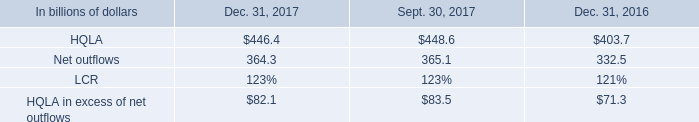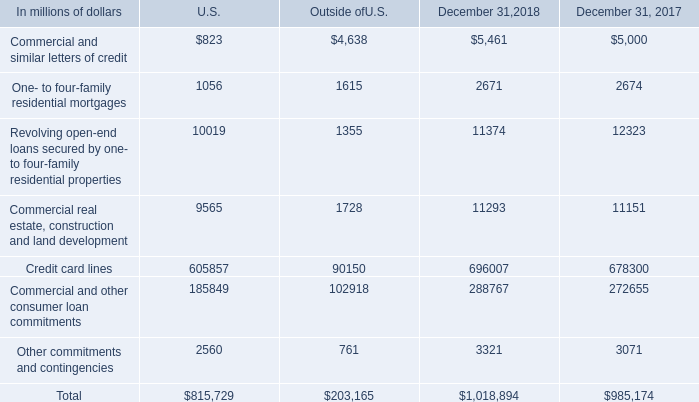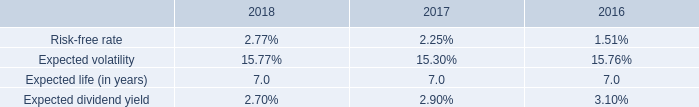What is the proportion of Commercial and similar letters of credit to the total in 2018 for U.S. ? 
Computations: (823 / 815729)
Answer: 0.00101. 